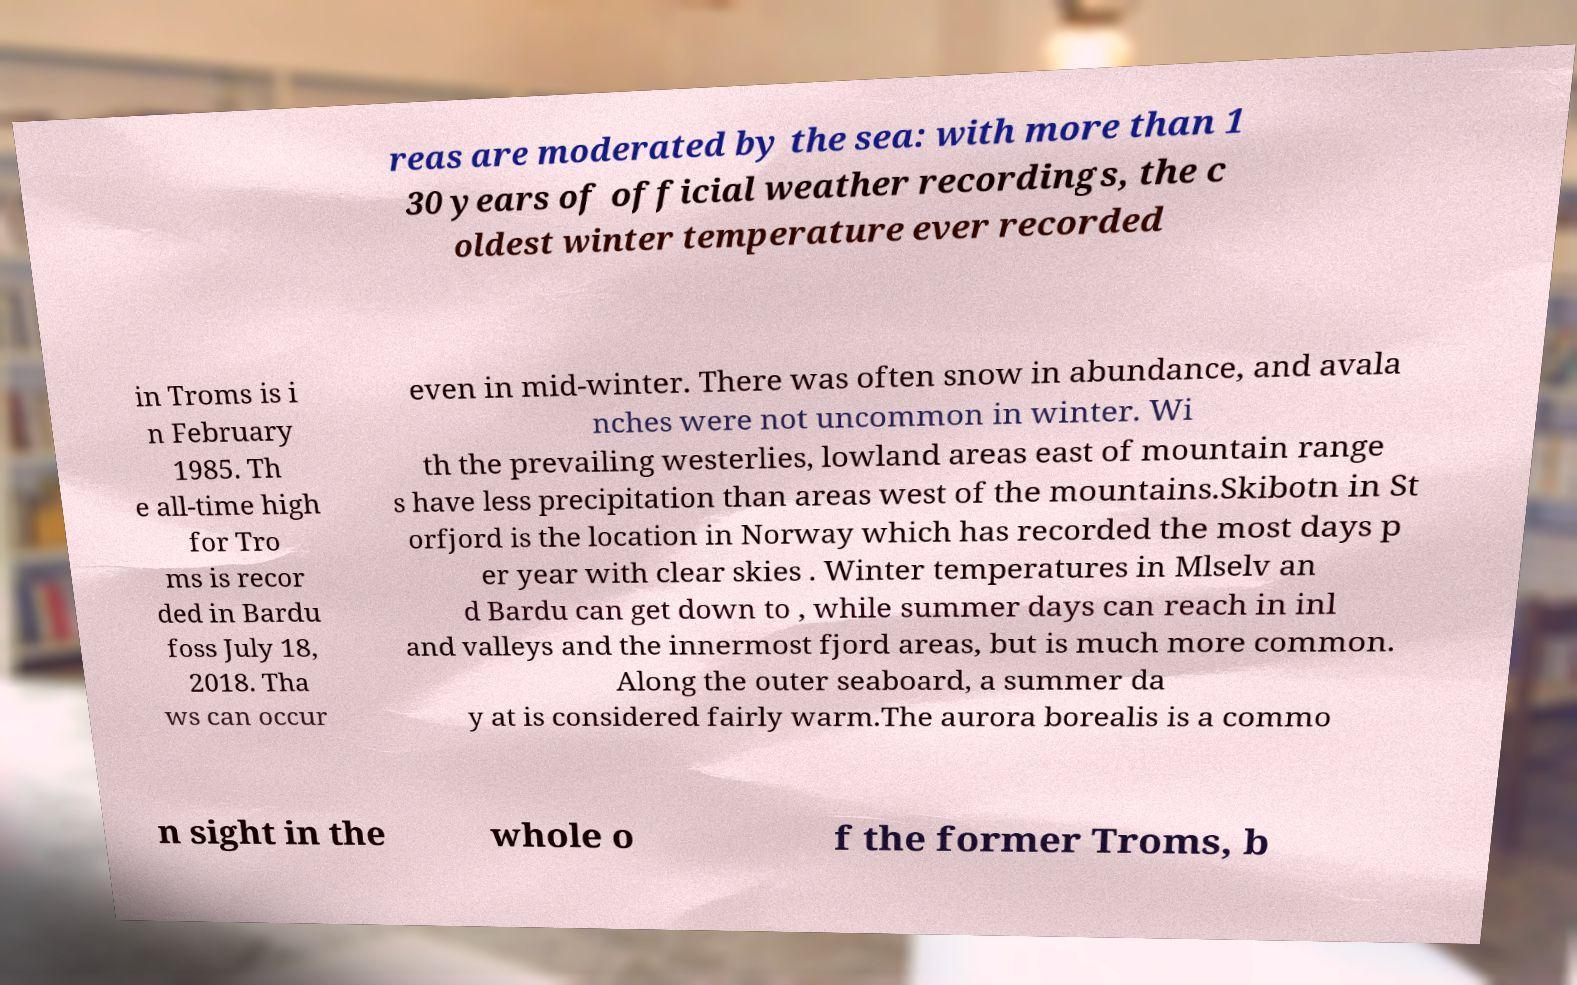Can you read and provide the text displayed in the image?This photo seems to have some interesting text. Can you extract and type it out for me? reas are moderated by the sea: with more than 1 30 years of official weather recordings, the c oldest winter temperature ever recorded in Troms is i n February 1985. Th e all-time high for Tro ms is recor ded in Bardu foss July 18, 2018. Tha ws can occur even in mid-winter. There was often snow in abundance, and avala nches were not uncommon in winter. Wi th the prevailing westerlies, lowland areas east of mountain range s have less precipitation than areas west of the mountains.Skibotn in St orfjord is the location in Norway which has recorded the most days p er year with clear skies . Winter temperatures in Mlselv an d Bardu can get down to , while summer days can reach in inl and valleys and the innermost fjord areas, but is much more common. Along the outer seaboard, a summer da y at is considered fairly warm.The aurora borealis is a commo n sight in the whole o f the former Troms, b 